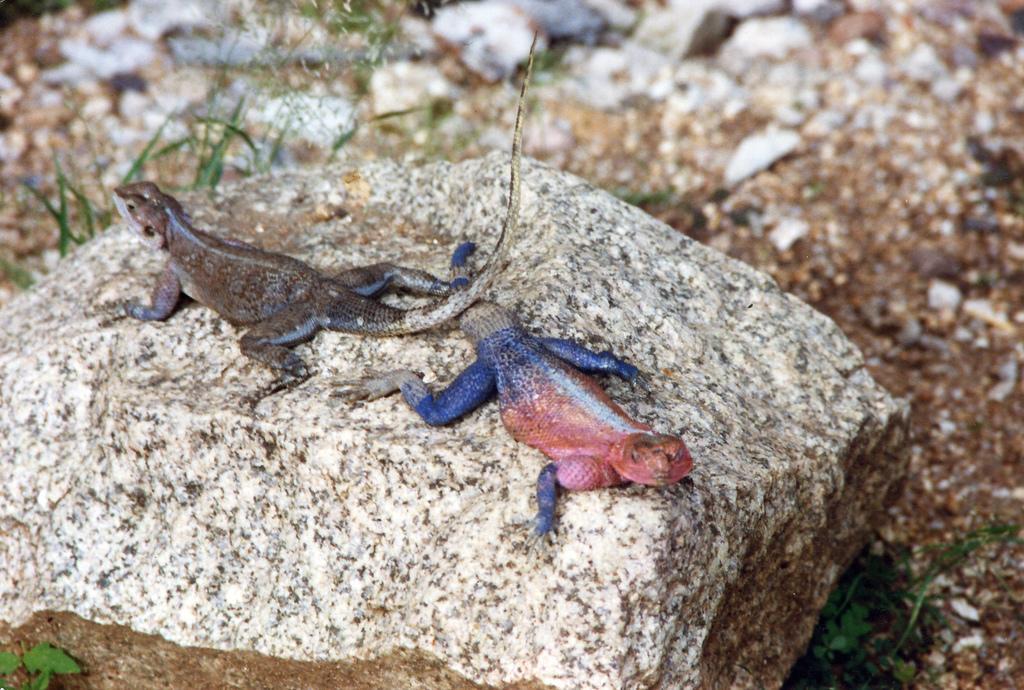Can you describe this image briefly? There is a stone. On that there are two chameleons. In the back there is grass and is looking blurred. 